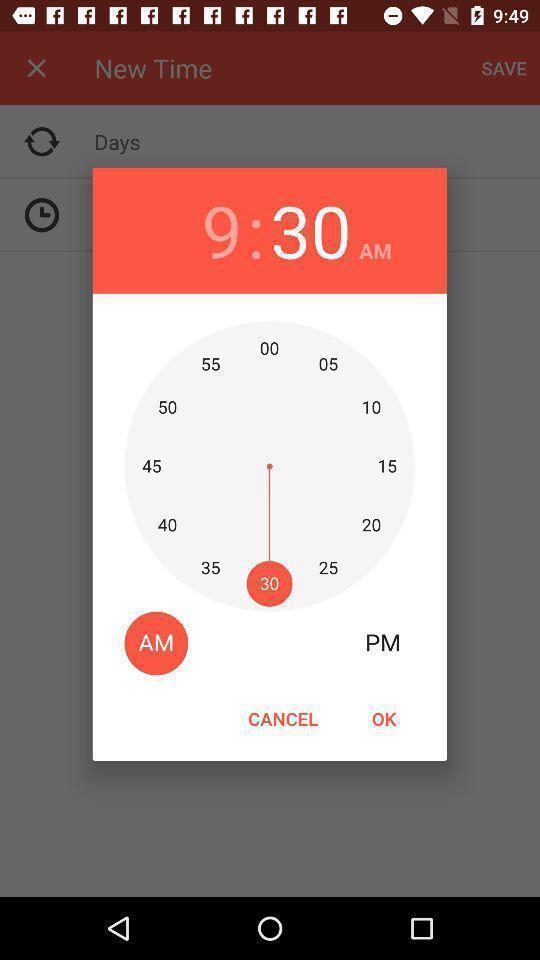Tell me what you see in this picture. Screen shows to set time. 